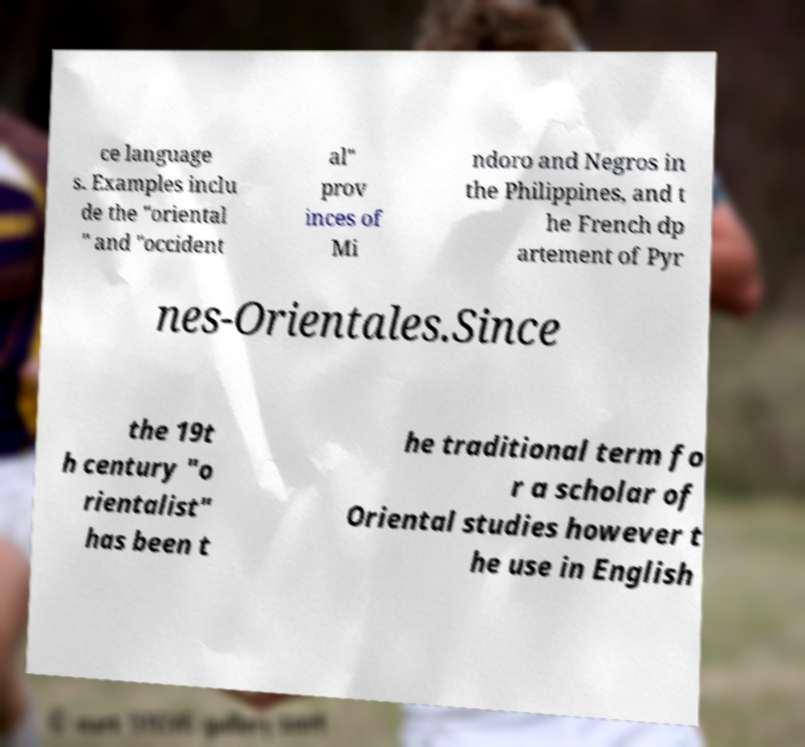Can you read and provide the text displayed in the image?This photo seems to have some interesting text. Can you extract and type it out for me? ce language s. Examples inclu de the "oriental " and "occident al" prov inces of Mi ndoro and Negros in the Philippines, and t he French dp artement of Pyr nes-Orientales.Since the 19t h century "o rientalist" has been t he traditional term fo r a scholar of Oriental studies however t he use in English 